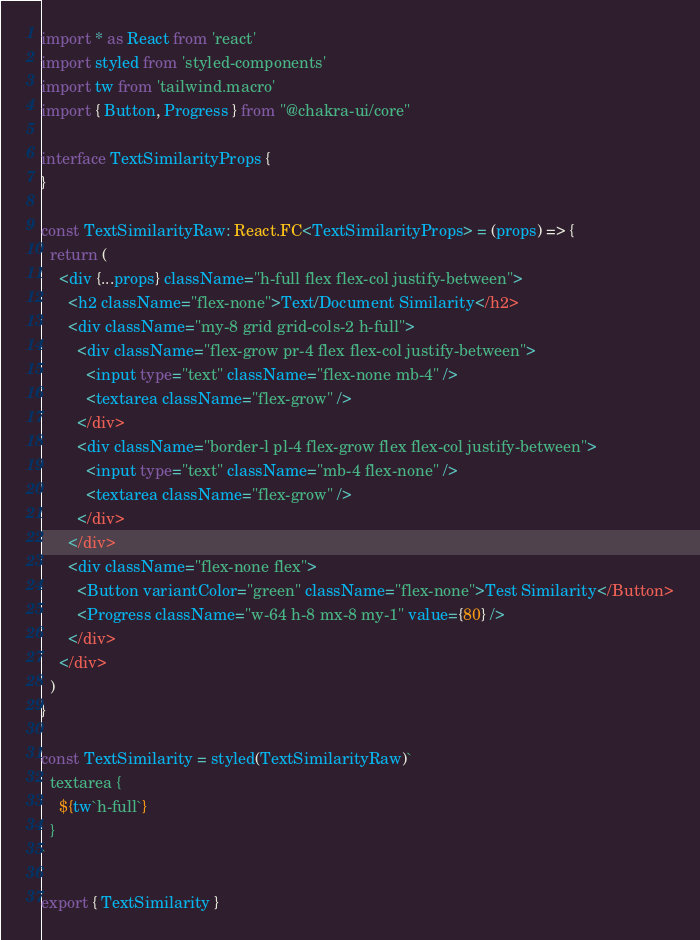<code> <loc_0><loc_0><loc_500><loc_500><_TypeScript_>import * as React from 'react'
import styled from 'styled-components'
import tw from 'tailwind.macro'
import { Button, Progress } from "@chakra-ui/core"

interface TextSimilarityProps {
}

const TextSimilarityRaw: React.FC<TextSimilarityProps> = (props) => {
  return (
    <div {...props} className="h-full flex flex-col justify-between">
      <h2 className="flex-none">Text/Document Similarity</h2>
      <div className="my-8 grid grid-cols-2 h-full">
        <div className="flex-grow pr-4 flex flex-col justify-between">
          <input type="text" className="flex-none mb-4" />
          <textarea className="flex-grow" />
        </div>
        <div className="border-l pl-4 flex-grow flex flex-col justify-between">
          <input type="text" className="mb-4 flex-none" />
          <textarea className="flex-grow" />
        </div>
      </div>
      <div className="flex-none flex">
        <Button variantColor="green" className="flex-none">Test Similarity</Button>
        <Progress className="w-64 h-8 mx-8 my-1" value={80} />
      </div>
    </div>
  )
}

const TextSimilarity = styled(TextSimilarityRaw)`
  textarea {
    ${tw`h-full`}
  }
`

export { TextSimilarity }</code> 